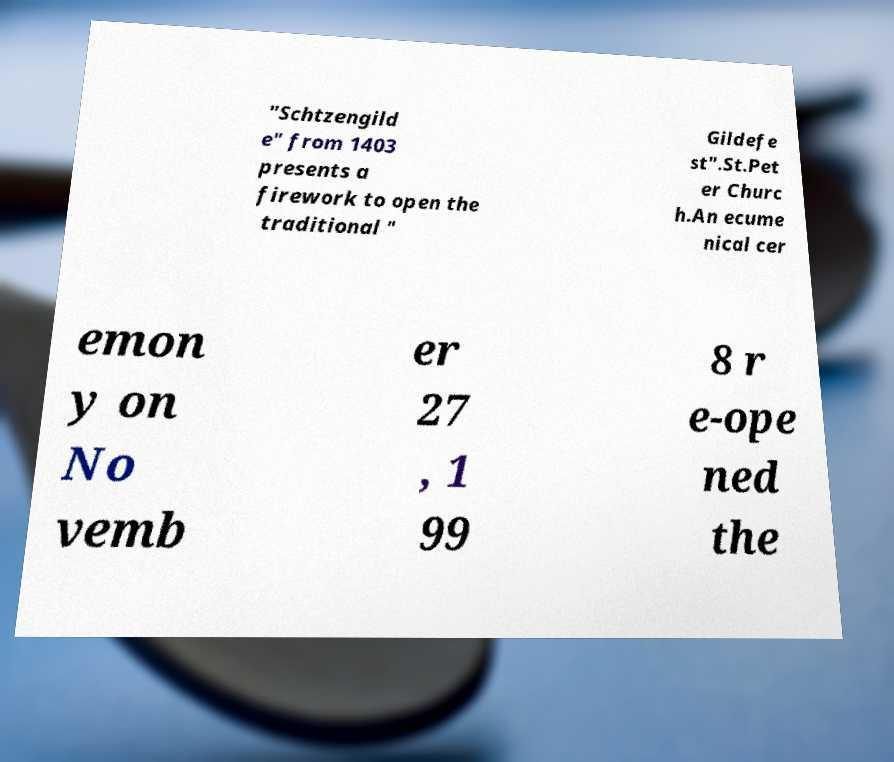Please identify and transcribe the text found in this image. "Schtzengild e" from 1403 presents a firework to open the traditional " Gildefe st".St.Pet er Churc h.An ecume nical cer emon y on No vemb er 27 , 1 99 8 r e-ope ned the 